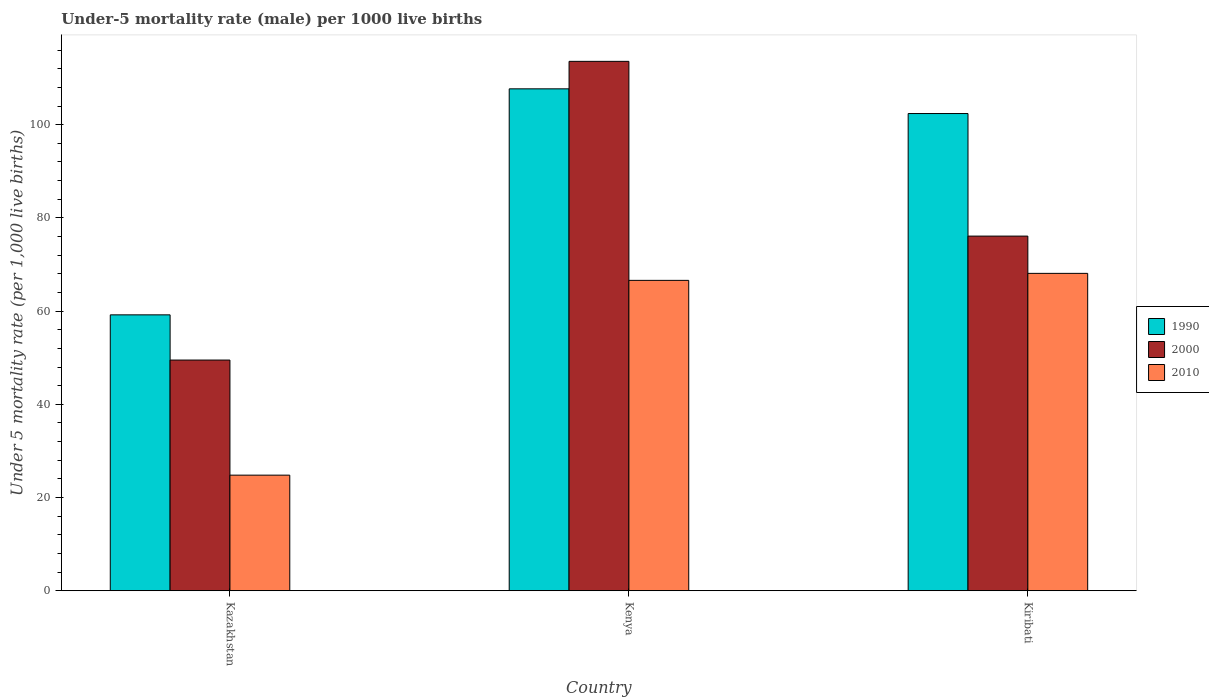How many groups of bars are there?
Ensure brevity in your answer.  3. How many bars are there on the 2nd tick from the right?
Your answer should be compact. 3. What is the label of the 3rd group of bars from the left?
Your answer should be compact. Kiribati. What is the under-five mortality rate in 1990 in Kiribati?
Ensure brevity in your answer.  102.4. Across all countries, what is the maximum under-five mortality rate in 2000?
Give a very brief answer. 113.6. Across all countries, what is the minimum under-five mortality rate in 1990?
Make the answer very short. 59.2. In which country was the under-five mortality rate in 1990 maximum?
Keep it short and to the point. Kenya. In which country was the under-five mortality rate in 1990 minimum?
Give a very brief answer. Kazakhstan. What is the total under-five mortality rate in 2000 in the graph?
Offer a very short reply. 239.2. What is the difference between the under-five mortality rate in 1990 in Kazakhstan and that in Kiribati?
Offer a terse response. -43.2. What is the difference between the under-five mortality rate in 2010 in Kazakhstan and the under-five mortality rate in 1990 in Kenya?
Provide a short and direct response. -82.9. What is the average under-five mortality rate in 2010 per country?
Make the answer very short. 53.17. What is the difference between the under-five mortality rate of/in 2000 and under-five mortality rate of/in 1990 in Kazakhstan?
Provide a succinct answer. -9.7. In how many countries, is the under-five mortality rate in 1990 greater than 32?
Provide a short and direct response. 3. What is the ratio of the under-five mortality rate in 2000 in Kenya to that in Kiribati?
Your answer should be compact. 1.49. Is the under-five mortality rate in 2000 in Kenya less than that in Kiribati?
Ensure brevity in your answer.  No. What is the difference between the highest and the second highest under-five mortality rate in 2010?
Provide a short and direct response. -41.8. What is the difference between the highest and the lowest under-five mortality rate in 2000?
Offer a terse response. 64.1. Is the sum of the under-five mortality rate in 2000 in Kazakhstan and Kiribati greater than the maximum under-five mortality rate in 1990 across all countries?
Your answer should be very brief. Yes. What does the 3rd bar from the right in Kiribati represents?
Give a very brief answer. 1990. What is the difference between two consecutive major ticks on the Y-axis?
Make the answer very short. 20. Does the graph contain any zero values?
Your answer should be very brief. No. Where does the legend appear in the graph?
Make the answer very short. Center right. How are the legend labels stacked?
Your answer should be very brief. Vertical. What is the title of the graph?
Your answer should be very brief. Under-5 mortality rate (male) per 1000 live births. What is the label or title of the X-axis?
Offer a very short reply. Country. What is the label or title of the Y-axis?
Your response must be concise. Under 5 mortality rate (per 1,0 live births). What is the Under 5 mortality rate (per 1,000 live births) in 1990 in Kazakhstan?
Provide a short and direct response. 59.2. What is the Under 5 mortality rate (per 1,000 live births) in 2000 in Kazakhstan?
Keep it short and to the point. 49.5. What is the Under 5 mortality rate (per 1,000 live births) of 2010 in Kazakhstan?
Offer a terse response. 24.8. What is the Under 5 mortality rate (per 1,000 live births) of 1990 in Kenya?
Offer a very short reply. 107.7. What is the Under 5 mortality rate (per 1,000 live births) in 2000 in Kenya?
Offer a very short reply. 113.6. What is the Under 5 mortality rate (per 1,000 live births) of 2010 in Kenya?
Keep it short and to the point. 66.6. What is the Under 5 mortality rate (per 1,000 live births) of 1990 in Kiribati?
Provide a short and direct response. 102.4. What is the Under 5 mortality rate (per 1,000 live births) of 2000 in Kiribati?
Offer a very short reply. 76.1. What is the Under 5 mortality rate (per 1,000 live births) in 2010 in Kiribati?
Your answer should be compact. 68.1. Across all countries, what is the maximum Under 5 mortality rate (per 1,000 live births) in 1990?
Provide a short and direct response. 107.7. Across all countries, what is the maximum Under 5 mortality rate (per 1,000 live births) in 2000?
Make the answer very short. 113.6. Across all countries, what is the maximum Under 5 mortality rate (per 1,000 live births) in 2010?
Keep it short and to the point. 68.1. Across all countries, what is the minimum Under 5 mortality rate (per 1,000 live births) in 1990?
Your answer should be very brief. 59.2. Across all countries, what is the minimum Under 5 mortality rate (per 1,000 live births) of 2000?
Offer a very short reply. 49.5. Across all countries, what is the minimum Under 5 mortality rate (per 1,000 live births) in 2010?
Give a very brief answer. 24.8. What is the total Under 5 mortality rate (per 1,000 live births) in 1990 in the graph?
Your response must be concise. 269.3. What is the total Under 5 mortality rate (per 1,000 live births) of 2000 in the graph?
Your answer should be very brief. 239.2. What is the total Under 5 mortality rate (per 1,000 live births) in 2010 in the graph?
Provide a succinct answer. 159.5. What is the difference between the Under 5 mortality rate (per 1,000 live births) in 1990 in Kazakhstan and that in Kenya?
Provide a succinct answer. -48.5. What is the difference between the Under 5 mortality rate (per 1,000 live births) in 2000 in Kazakhstan and that in Kenya?
Give a very brief answer. -64.1. What is the difference between the Under 5 mortality rate (per 1,000 live births) of 2010 in Kazakhstan and that in Kenya?
Keep it short and to the point. -41.8. What is the difference between the Under 5 mortality rate (per 1,000 live births) in 1990 in Kazakhstan and that in Kiribati?
Ensure brevity in your answer.  -43.2. What is the difference between the Under 5 mortality rate (per 1,000 live births) in 2000 in Kazakhstan and that in Kiribati?
Ensure brevity in your answer.  -26.6. What is the difference between the Under 5 mortality rate (per 1,000 live births) in 2010 in Kazakhstan and that in Kiribati?
Give a very brief answer. -43.3. What is the difference between the Under 5 mortality rate (per 1,000 live births) of 2000 in Kenya and that in Kiribati?
Give a very brief answer. 37.5. What is the difference between the Under 5 mortality rate (per 1,000 live births) in 1990 in Kazakhstan and the Under 5 mortality rate (per 1,000 live births) in 2000 in Kenya?
Provide a succinct answer. -54.4. What is the difference between the Under 5 mortality rate (per 1,000 live births) of 1990 in Kazakhstan and the Under 5 mortality rate (per 1,000 live births) of 2010 in Kenya?
Your answer should be very brief. -7.4. What is the difference between the Under 5 mortality rate (per 1,000 live births) in 2000 in Kazakhstan and the Under 5 mortality rate (per 1,000 live births) in 2010 in Kenya?
Offer a very short reply. -17.1. What is the difference between the Under 5 mortality rate (per 1,000 live births) in 1990 in Kazakhstan and the Under 5 mortality rate (per 1,000 live births) in 2000 in Kiribati?
Offer a very short reply. -16.9. What is the difference between the Under 5 mortality rate (per 1,000 live births) of 1990 in Kazakhstan and the Under 5 mortality rate (per 1,000 live births) of 2010 in Kiribati?
Your response must be concise. -8.9. What is the difference between the Under 5 mortality rate (per 1,000 live births) in 2000 in Kazakhstan and the Under 5 mortality rate (per 1,000 live births) in 2010 in Kiribati?
Offer a terse response. -18.6. What is the difference between the Under 5 mortality rate (per 1,000 live births) of 1990 in Kenya and the Under 5 mortality rate (per 1,000 live births) of 2000 in Kiribati?
Ensure brevity in your answer.  31.6. What is the difference between the Under 5 mortality rate (per 1,000 live births) in 1990 in Kenya and the Under 5 mortality rate (per 1,000 live births) in 2010 in Kiribati?
Keep it short and to the point. 39.6. What is the difference between the Under 5 mortality rate (per 1,000 live births) in 2000 in Kenya and the Under 5 mortality rate (per 1,000 live births) in 2010 in Kiribati?
Ensure brevity in your answer.  45.5. What is the average Under 5 mortality rate (per 1,000 live births) of 1990 per country?
Provide a succinct answer. 89.77. What is the average Under 5 mortality rate (per 1,000 live births) in 2000 per country?
Offer a terse response. 79.73. What is the average Under 5 mortality rate (per 1,000 live births) in 2010 per country?
Offer a very short reply. 53.17. What is the difference between the Under 5 mortality rate (per 1,000 live births) in 1990 and Under 5 mortality rate (per 1,000 live births) in 2000 in Kazakhstan?
Give a very brief answer. 9.7. What is the difference between the Under 5 mortality rate (per 1,000 live births) of 1990 and Under 5 mortality rate (per 1,000 live births) of 2010 in Kazakhstan?
Provide a succinct answer. 34.4. What is the difference between the Under 5 mortality rate (per 1,000 live births) in 2000 and Under 5 mortality rate (per 1,000 live births) in 2010 in Kazakhstan?
Offer a terse response. 24.7. What is the difference between the Under 5 mortality rate (per 1,000 live births) of 1990 and Under 5 mortality rate (per 1,000 live births) of 2000 in Kenya?
Offer a very short reply. -5.9. What is the difference between the Under 5 mortality rate (per 1,000 live births) of 1990 and Under 5 mortality rate (per 1,000 live births) of 2010 in Kenya?
Make the answer very short. 41.1. What is the difference between the Under 5 mortality rate (per 1,000 live births) of 2000 and Under 5 mortality rate (per 1,000 live births) of 2010 in Kenya?
Make the answer very short. 47. What is the difference between the Under 5 mortality rate (per 1,000 live births) in 1990 and Under 5 mortality rate (per 1,000 live births) in 2000 in Kiribati?
Your response must be concise. 26.3. What is the difference between the Under 5 mortality rate (per 1,000 live births) of 1990 and Under 5 mortality rate (per 1,000 live births) of 2010 in Kiribati?
Your answer should be very brief. 34.3. What is the ratio of the Under 5 mortality rate (per 1,000 live births) of 1990 in Kazakhstan to that in Kenya?
Offer a very short reply. 0.55. What is the ratio of the Under 5 mortality rate (per 1,000 live births) in 2000 in Kazakhstan to that in Kenya?
Make the answer very short. 0.44. What is the ratio of the Under 5 mortality rate (per 1,000 live births) of 2010 in Kazakhstan to that in Kenya?
Provide a short and direct response. 0.37. What is the ratio of the Under 5 mortality rate (per 1,000 live births) in 1990 in Kazakhstan to that in Kiribati?
Keep it short and to the point. 0.58. What is the ratio of the Under 5 mortality rate (per 1,000 live births) in 2000 in Kazakhstan to that in Kiribati?
Provide a succinct answer. 0.65. What is the ratio of the Under 5 mortality rate (per 1,000 live births) of 2010 in Kazakhstan to that in Kiribati?
Offer a terse response. 0.36. What is the ratio of the Under 5 mortality rate (per 1,000 live births) of 1990 in Kenya to that in Kiribati?
Ensure brevity in your answer.  1.05. What is the ratio of the Under 5 mortality rate (per 1,000 live births) of 2000 in Kenya to that in Kiribati?
Provide a short and direct response. 1.49. What is the difference between the highest and the second highest Under 5 mortality rate (per 1,000 live births) in 2000?
Offer a very short reply. 37.5. What is the difference between the highest and the second highest Under 5 mortality rate (per 1,000 live births) of 2010?
Your response must be concise. 1.5. What is the difference between the highest and the lowest Under 5 mortality rate (per 1,000 live births) of 1990?
Make the answer very short. 48.5. What is the difference between the highest and the lowest Under 5 mortality rate (per 1,000 live births) of 2000?
Provide a succinct answer. 64.1. What is the difference between the highest and the lowest Under 5 mortality rate (per 1,000 live births) of 2010?
Give a very brief answer. 43.3. 